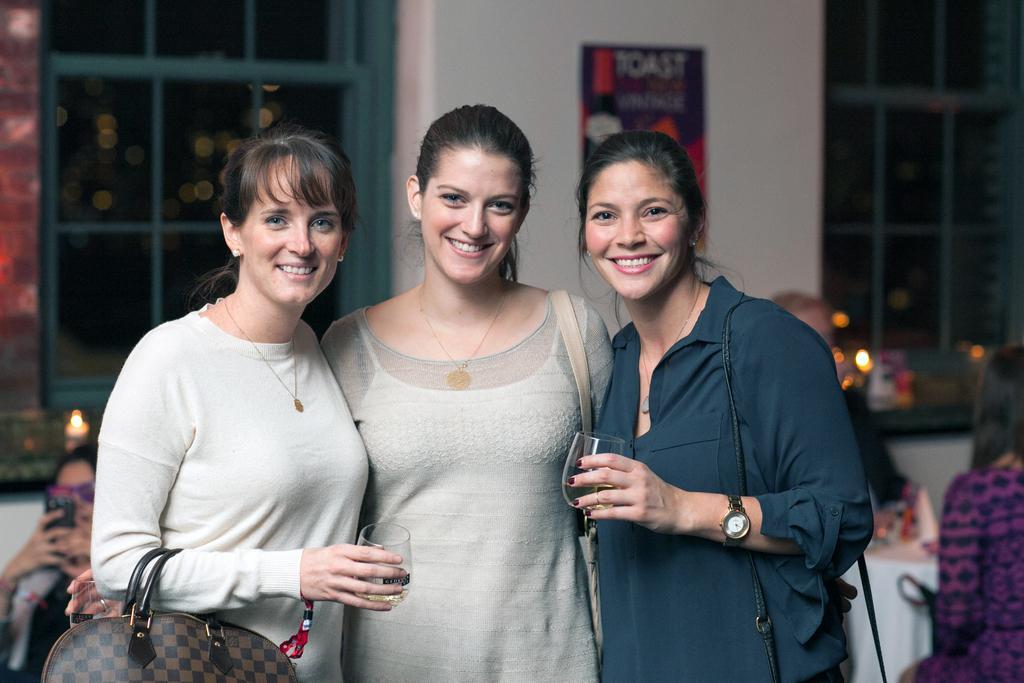Can you describe this image briefly? There are two women standing and holding a glass in their hands and there is another woman standing in between them and there are few other people behind them. 